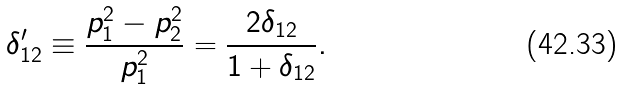<formula> <loc_0><loc_0><loc_500><loc_500>\delta _ { 1 2 } ^ { \prime } \equiv \frac { p _ { 1 } ^ { 2 } - p _ { 2 } ^ { 2 } } { p _ { 1 } ^ { 2 } } = \frac { 2 \delta _ { 1 2 } } { 1 + \delta _ { 1 2 } } .</formula> 